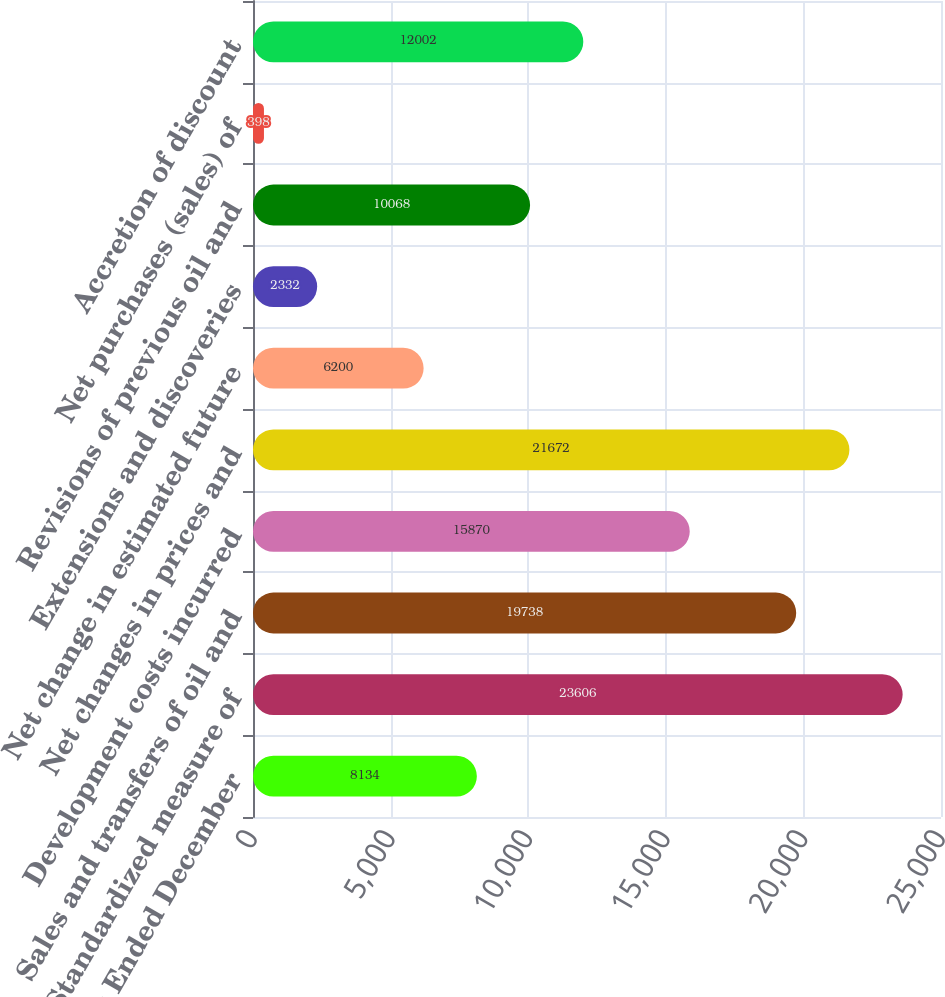Convert chart to OTSL. <chart><loc_0><loc_0><loc_500><loc_500><bar_chart><fcel>For the Years Ended December<fcel>Standardized measure of<fcel>Sales and transfers of oil and<fcel>Development costs incurred<fcel>Net changes in prices and<fcel>Net change in estimated future<fcel>Extensions and discoveries<fcel>Revisions of previous oil and<fcel>Net purchases (sales) of<fcel>Accretion of discount<nl><fcel>8134<fcel>23606<fcel>19738<fcel>15870<fcel>21672<fcel>6200<fcel>2332<fcel>10068<fcel>398<fcel>12002<nl></chart> 